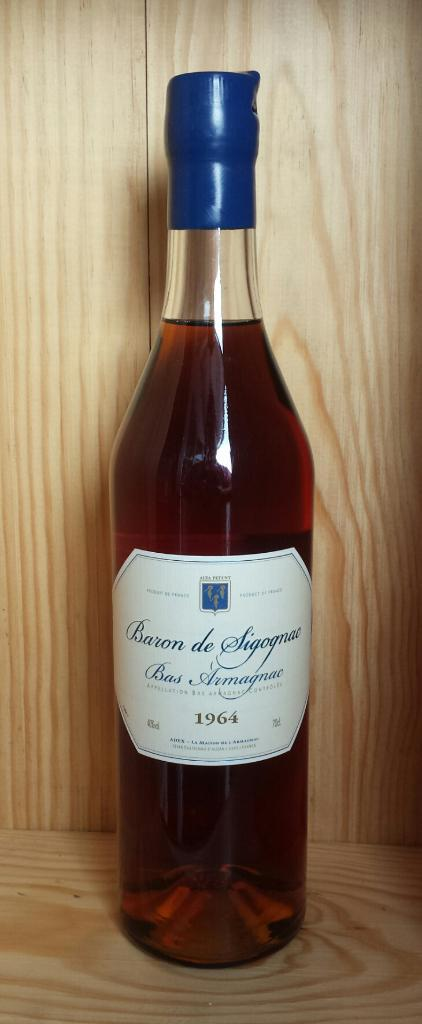<image>
Render a clear and concise summary of the photo. 1964 bottle of baron de sigognao bas armagnac on a wooden shelf 